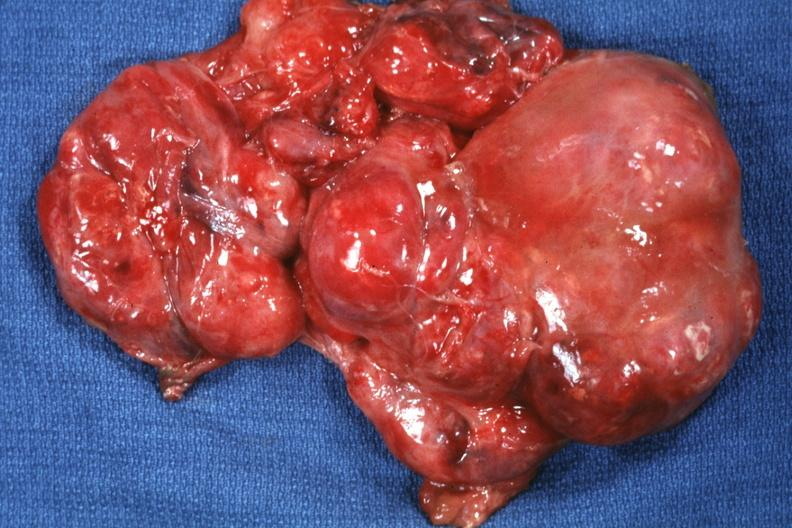does this image show excised tumor?
Answer the question using a single word or phrase. Yes 